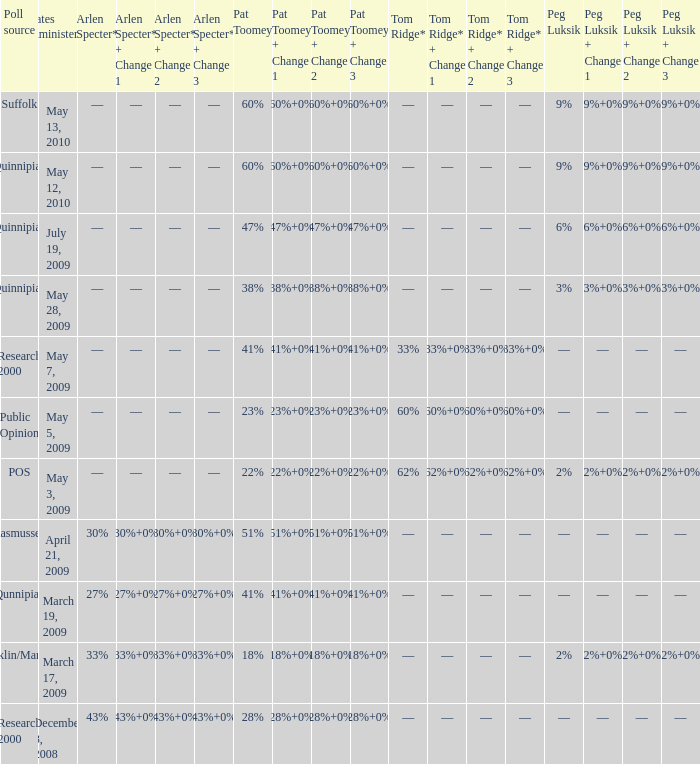Parse the table in full. {'header': ['Poll source', 'Dates administered', 'Arlen Specter*', 'Arlen Specter* + Change 1', 'Arlen Specter* + Change 2', 'Arlen Specter* + Change 3', 'Pat Toomey', 'Pat Toomey + Change 1', 'Pat Toomey + Change 2', 'Pat Toomey + Change 3', 'Tom Ridge*', 'Tom Ridge* + Change 1', 'Tom Ridge* + Change 2', 'Tom Ridge* + Change 3', 'Peg Luksik', 'Peg Luksik + Change 1', 'Peg Luksik + Change 2', 'Peg Luksik + Change 3'], 'rows': [['Suffolk', 'May 13, 2010', '––', '––', '––', '––', '60%', '60%+0%', '60%+0%', '60%+0%', '––', '––', '––', '––', '9%', '9%+0%', '9%+0%', '9%+0%'], ['Quinnipiac', 'May 12, 2010', '––', '––', '––', '––', '60%', '60%+0%', '60%+0%', '60%+0%', '––', '––', '––', '––', '9%', '9%+0%', '9%+0%', '9%+0%'], ['Quinnipiac', 'July 19, 2009', '––', '––', '––', '––', '47%', '47%+0%', '47%+0%', '47%+0%', '––', '––', '––', '––', '6%', '6%+0%', '6%+0%', '6%+0%'], ['Quinnipiac', 'May 28, 2009', '––', '––', '––', '––', '38%', '38%+0%', '38%+0%', '38%+0%', '––', '––', '––', '––', '3%', '3%+0%', '3%+0%', '3%+0%'], ['Research 2000', 'May 7, 2009', '––', '––', '––', '––', '41%', '41%+0%', '41%+0%', '41%+0%', '33%', '33%+0%', '33%+0%', '33%+0%', '––', '––', '––', '––'], ['Public Opinion', 'May 5, 2009', '––', '––', '––', '––', '23%', '23%+0%', '23%+0%', '23%+0%', '60%', '60%+0%', '60%+0%', '60%+0%', '––', '––', '––', '––'], ['POS', 'May 3, 2009', '––', '––', '––', '––', '22%', '22%+0%', '22%+0%', '22%+0%', '62%', '62%+0%', '62%+0%', '62%+0%', '2%', '2%+0%', '2%+0%', '2%+0%'], ['Rasmussen', 'April 21, 2009', '30%', '30%+0%', '30%+0%', '30%+0%', '51%', '51%+0%', '51%+0%', '51%+0%', '––', '––', '––', '––', '––', '––', '––', '––'], ['Qunnipiac', 'March 19, 2009', '27%', '27%+0%', '27%+0%', '27%+0%', '41%', '41%+0%', '41%+0%', '41%+0%', '––', '––', '––', '––', '––', '––', '––', '––'], ['Franklin/Marshall', 'March 17, 2009', '33%', '33%+0%', '33%+0%', '33%+0%', '18%', '18%+0%', '18%+0%', '18%+0%', '––', '––', '––', '––', '2%', '2%+0%', '2%+0%', '2%+0%'], ['Research 2000', 'December 8, 2008', '43%', '43%+0%', '43%+0%', '43%+0%', '28%', '28%+0%', '28%+0%', '28%+0%', '––', '––', '––', '––', '––', '––', '––', '––']]} Which Tom Ridge* has a Poll source of research 2000, and an Arlen Specter* of 43%? ––. 